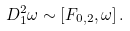<formula> <loc_0><loc_0><loc_500><loc_500>D _ { 1 } ^ { 2 } \omega \sim [ F _ { 0 , 2 } , \omega ] \, .</formula> 